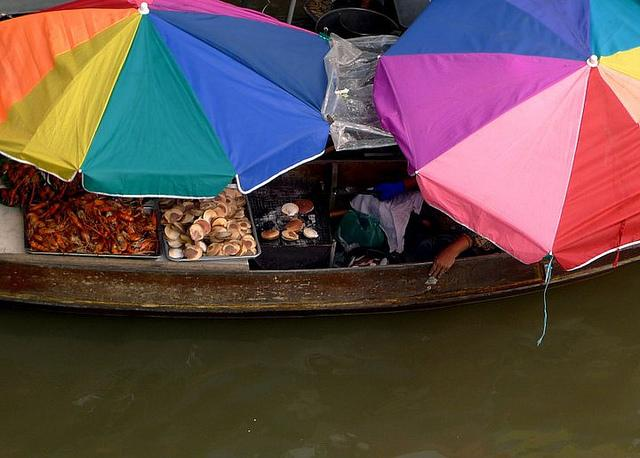What sort of food is being moved here? Please explain your reasoning. seafood. Shellfish and other seafood can be clearly seen. beef, chicken, and goat do not come in shells. 